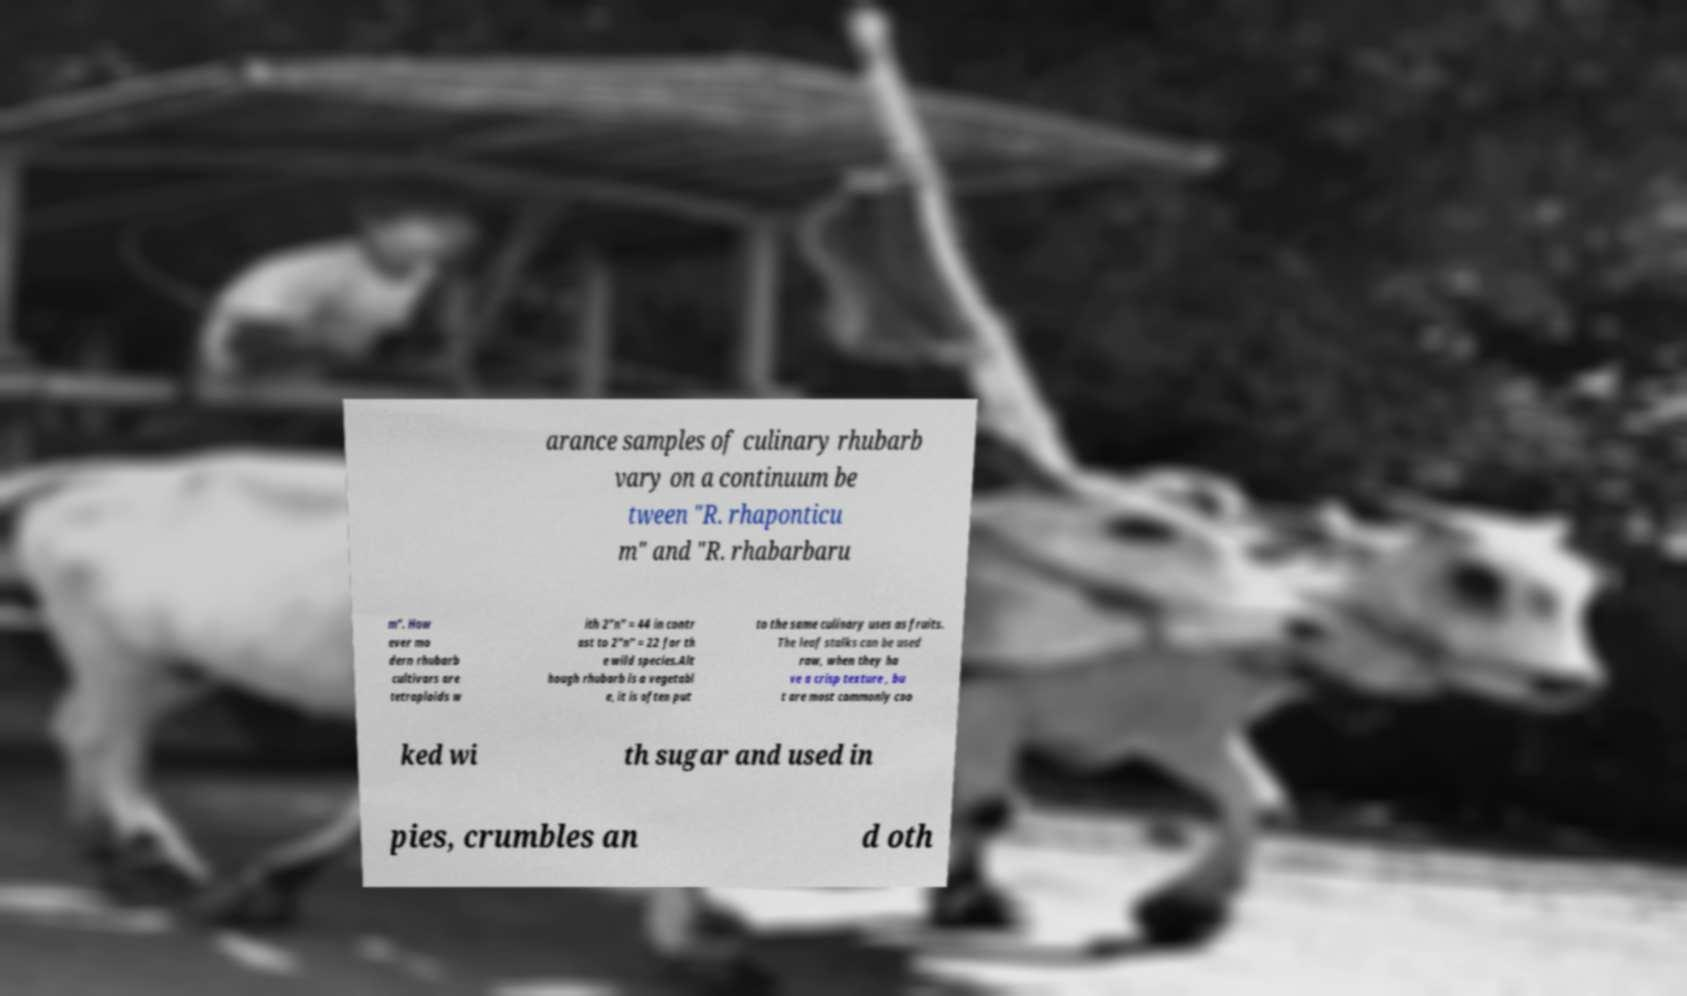For documentation purposes, I need the text within this image transcribed. Could you provide that? arance samples of culinary rhubarb vary on a continuum be tween "R. rhaponticu m" and "R. rhabarbaru m". How ever mo dern rhubarb cultivars are tetraploids w ith 2"n" = 44 in contr ast to 2"n" = 22 for th e wild species.Alt hough rhubarb is a vegetabl e, it is often put to the same culinary uses as fruits. The leaf stalks can be used raw, when they ha ve a crisp texture , bu t are most commonly coo ked wi th sugar and used in pies, crumbles an d oth 